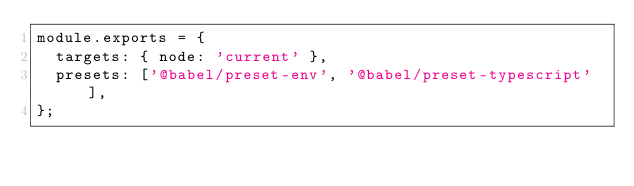Convert code to text. <code><loc_0><loc_0><loc_500><loc_500><_JavaScript_>module.exports = {
  targets: { node: 'current' },
  presets: ['@babel/preset-env', '@babel/preset-typescript'],
};
</code> 